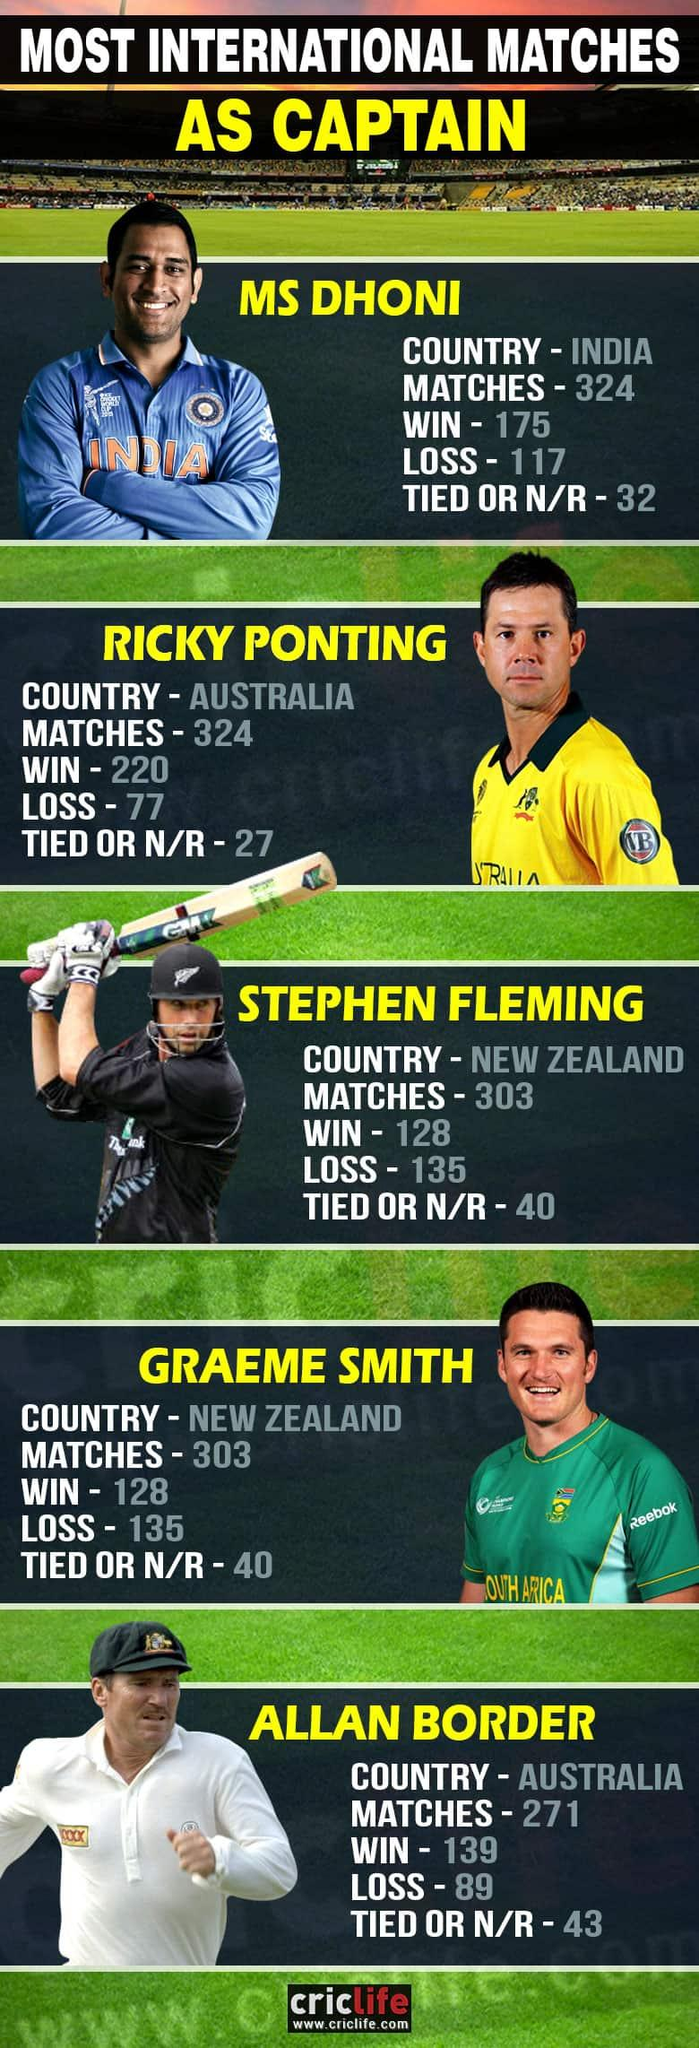Point out several critical features in this image. VB is the sponsor of Australia Cricket. It is widely recognized that Ricky Ponting is the most successful cricket captain of all time. Reebok is the sponsor of the South African cricket team. Allan Border, the Australian captain, has lost more matches than any other captain in Australian cricket history. There are two cricketers from Australia listed. 